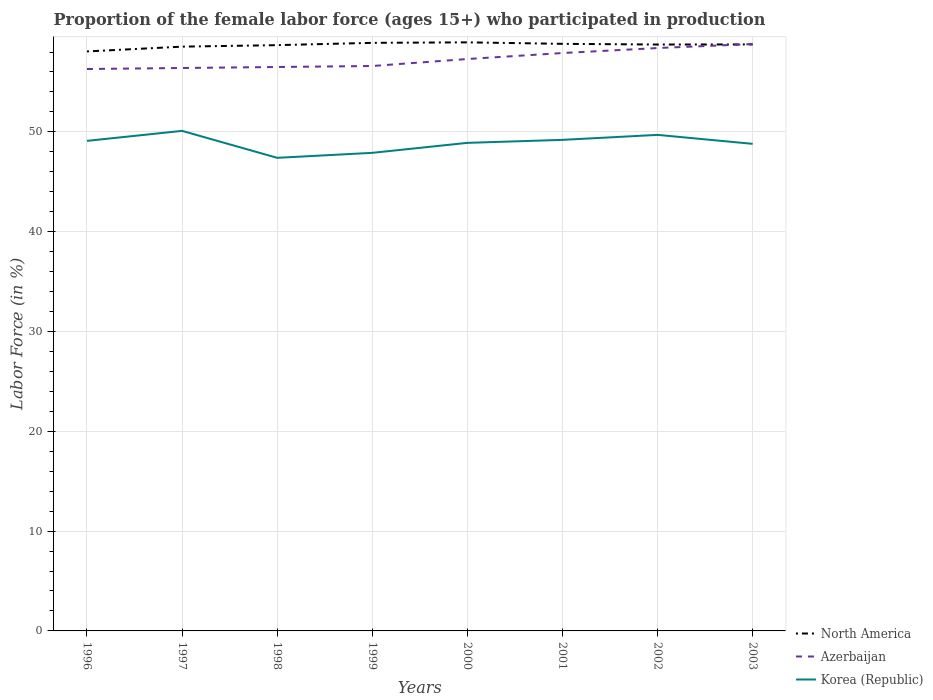How many different coloured lines are there?
Your answer should be compact. 3. Does the line corresponding to Azerbaijan intersect with the line corresponding to North America?
Your answer should be compact. Yes. Is the number of lines equal to the number of legend labels?
Offer a terse response. Yes. Across all years, what is the maximum proportion of the female labor force who participated in production in Azerbaijan?
Make the answer very short. 56.3. What is the total proportion of the female labor force who participated in production in North America in the graph?
Provide a short and direct response. 0.21. What is the difference between the highest and the second highest proportion of the female labor force who participated in production in Korea (Republic)?
Offer a terse response. 2.7. Is the proportion of the female labor force who participated in production in North America strictly greater than the proportion of the female labor force who participated in production in Korea (Republic) over the years?
Ensure brevity in your answer.  No. How many lines are there?
Your response must be concise. 3. How many years are there in the graph?
Provide a succinct answer. 8. What is the difference between two consecutive major ticks on the Y-axis?
Give a very brief answer. 10. Are the values on the major ticks of Y-axis written in scientific E-notation?
Ensure brevity in your answer.  No. Does the graph contain grids?
Provide a succinct answer. Yes. How are the legend labels stacked?
Offer a terse response. Vertical. What is the title of the graph?
Ensure brevity in your answer.  Proportion of the female labor force (ages 15+) who participated in production. Does "Timor-Leste" appear as one of the legend labels in the graph?
Provide a succinct answer. No. What is the label or title of the Y-axis?
Ensure brevity in your answer.  Labor Force (in %). What is the Labor Force (in %) of North America in 1996?
Give a very brief answer. 58.06. What is the Labor Force (in %) in Azerbaijan in 1996?
Keep it short and to the point. 56.3. What is the Labor Force (in %) of Korea (Republic) in 1996?
Offer a terse response. 49.1. What is the Labor Force (in %) of North America in 1997?
Your answer should be very brief. 58.54. What is the Labor Force (in %) in Azerbaijan in 1997?
Provide a succinct answer. 56.4. What is the Labor Force (in %) in Korea (Republic) in 1997?
Give a very brief answer. 50.1. What is the Labor Force (in %) in North America in 1998?
Offer a terse response. 58.69. What is the Labor Force (in %) in Azerbaijan in 1998?
Your answer should be compact. 56.5. What is the Labor Force (in %) in Korea (Republic) in 1998?
Make the answer very short. 47.4. What is the Labor Force (in %) of North America in 1999?
Provide a short and direct response. 58.92. What is the Labor Force (in %) in Azerbaijan in 1999?
Provide a succinct answer. 56.6. What is the Labor Force (in %) in Korea (Republic) in 1999?
Provide a short and direct response. 47.9. What is the Labor Force (in %) in North America in 2000?
Your answer should be compact. 58.97. What is the Labor Force (in %) of Azerbaijan in 2000?
Make the answer very short. 57.3. What is the Labor Force (in %) of Korea (Republic) in 2000?
Offer a terse response. 48.9. What is the Labor Force (in %) of North America in 2001?
Keep it short and to the point. 58.82. What is the Labor Force (in %) of Azerbaijan in 2001?
Provide a succinct answer. 57.9. What is the Labor Force (in %) of Korea (Republic) in 2001?
Provide a succinct answer. 49.2. What is the Labor Force (in %) in North America in 2002?
Offer a very short reply. 58.75. What is the Labor Force (in %) of Azerbaijan in 2002?
Your response must be concise. 58.4. What is the Labor Force (in %) of Korea (Republic) in 2002?
Your response must be concise. 49.7. What is the Labor Force (in %) in North America in 2003?
Offer a very short reply. 58.76. What is the Labor Force (in %) of Azerbaijan in 2003?
Provide a succinct answer. 58.8. What is the Labor Force (in %) of Korea (Republic) in 2003?
Your response must be concise. 48.8. Across all years, what is the maximum Labor Force (in %) of North America?
Keep it short and to the point. 58.97. Across all years, what is the maximum Labor Force (in %) in Azerbaijan?
Provide a succinct answer. 58.8. Across all years, what is the maximum Labor Force (in %) of Korea (Republic)?
Keep it short and to the point. 50.1. Across all years, what is the minimum Labor Force (in %) in North America?
Offer a terse response. 58.06. Across all years, what is the minimum Labor Force (in %) in Azerbaijan?
Your answer should be compact. 56.3. Across all years, what is the minimum Labor Force (in %) in Korea (Republic)?
Give a very brief answer. 47.4. What is the total Labor Force (in %) in North America in the graph?
Provide a short and direct response. 469.51. What is the total Labor Force (in %) of Azerbaijan in the graph?
Keep it short and to the point. 458.2. What is the total Labor Force (in %) in Korea (Republic) in the graph?
Give a very brief answer. 391.1. What is the difference between the Labor Force (in %) in North America in 1996 and that in 1997?
Provide a short and direct response. -0.48. What is the difference between the Labor Force (in %) of North America in 1996 and that in 1998?
Your response must be concise. -0.63. What is the difference between the Labor Force (in %) of North America in 1996 and that in 1999?
Make the answer very short. -0.86. What is the difference between the Labor Force (in %) in Azerbaijan in 1996 and that in 1999?
Your answer should be very brief. -0.3. What is the difference between the Labor Force (in %) of Korea (Republic) in 1996 and that in 1999?
Your answer should be compact. 1.2. What is the difference between the Labor Force (in %) of North America in 1996 and that in 2000?
Provide a short and direct response. -0.91. What is the difference between the Labor Force (in %) of Azerbaijan in 1996 and that in 2000?
Offer a very short reply. -1. What is the difference between the Labor Force (in %) in North America in 1996 and that in 2001?
Your response must be concise. -0.76. What is the difference between the Labor Force (in %) in North America in 1996 and that in 2002?
Keep it short and to the point. -0.69. What is the difference between the Labor Force (in %) of Azerbaijan in 1996 and that in 2002?
Your response must be concise. -2.1. What is the difference between the Labor Force (in %) of North America in 1996 and that in 2003?
Your answer should be compact. -0.7. What is the difference between the Labor Force (in %) in Korea (Republic) in 1996 and that in 2003?
Provide a short and direct response. 0.3. What is the difference between the Labor Force (in %) in North America in 1997 and that in 1998?
Provide a short and direct response. -0.15. What is the difference between the Labor Force (in %) of Korea (Republic) in 1997 and that in 1998?
Make the answer very short. 2.7. What is the difference between the Labor Force (in %) of North America in 1997 and that in 1999?
Offer a very short reply. -0.38. What is the difference between the Labor Force (in %) in Azerbaijan in 1997 and that in 1999?
Keep it short and to the point. -0.2. What is the difference between the Labor Force (in %) in North America in 1997 and that in 2000?
Your answer should be very brief. -0.43. What is the difference between the Labor Force (in %) of Korea (Republic) in 1997 and that in 2000?
Offer a very short reply. 1.2. What is the difference between the Labor Force (in %) in North America in 1997 and that in 2001?
Your response must be concise. -0.28. What is the difference between the Labor Force (in %) of North America in 1997 and that in 2002?
Make the answer very short. -0.21. What is the difference between the Labor Force (in %) of Korea (Republic) in 1997 and that in 2002?
Provide a succinct answer. 0.4. What is the difference between the Labor Force (in %) of North America in 1997 and that in 2003?
Make the answer very short. -0.22. What is the difference between the Labor Force (in %) in Azerbaijan in 1997 and that in 2003?
Keep it short and to the point. -2.4. What is the difference between the Labor Force (in %) of Korea (Republic) in 1997 and that in 2003?
Offer a very short reply. 1.3. What is the difference between the Labor Force (in %) in North America in 1998 and that in 1999?
Provide a succinct answer. -0.23. What is the difference between the Labor Force (in %) in North America in 1998 and that in 2000?
Your answer should be very brief. -0.28. What is the difference between the Labor Force (in %) in North America in 1998 and that in 2001?
Your answer should be compact. -0.13. What is the difference between the Labor Force (in %) in Azerbaijan in 1998 and that in 2001?
Provide a short and direct response. -1.4. What is the difference between the Labor Force (in %) of North America in 1998 and that in 2002?
Provide a succinct answer. -0.06. What is the difference between the Labor Force (in %) of Azerbaijan in 1998 and that in 2002?
Offer a terse response. -1.9. What is the difference between the Labor Force (in %) of North America in 1998 and that in 2003?
Ensure brevity in your answer.  -0.07. What is the difference between the Labor Force (in %) of Azerbaijan in 1998 and that in 2003?
Keep it short and to the point. -2.3. What is the difference between the Labor Force (in %) in Korea (Republic) in 1998 and that in 2003?
Give a very brief answer. -1.4. What is the difference between the Labor Force (in %) in North America in 1999 and that in 2000?
Ensure brevity in your answer.  -0.05. What is the difference between the Labor Force (in %) of Azerbaijan in 1999 and that in 2000?
Your answer should be compact. -0.7. What is the difference between the Labor Force (in %) of North America in 1999 and that in 2001?
Your answer should be compact. 0.1. What is the difference between the Labor Force (in %) in Korea (Republic) in 1999 and that in 2001?
Your answer should be compact. -1.3. What is the difference between the Labor Force (in %) of North America in 1999 and that in 2002?
Ensure brevity in your answer.  0.17. What is the difference between the Labor Force (in %) in Azerbaijan in 1999 and that in 2002?
Offer a very short reply. -1.8. What is the difference between the Labor Force (in %) of North America in 1999 and that in 2003?
Your answer should be very brief. 0.16. What is the difference between the Labor Force (in %) in Korea (Republic) in 1999 and that in 2003?
Your answer should be very brief. -0.9. What is the difference between the Labor Force (in %) of North America in 2000 and that in 2001?
Ensure brevity in your answer.  0.15. What is the difference between the Labor Force (in %) in Azerbaijan in 2000 and that in 2001?
Offer a terse response. -0.6. What is the difference between the Labor Force (in %) of Korea (Republic) in 2000 and that in 2001?
Ensure brevity in your answer.  -0.3. What is the difference between the Labor Force (in %) in North America in 2000 and that in 2002?
Offer a very short reply. 0.22. What is the difference between the Labor Force (in %) of Korea (Republic) in 2000 and that in 2002?
Make the answer very short. -0.8. What is the difference between the Labor Force (in %) in North America in 2000 and that in 2003?
Your answer should be very brief. 0.21. What is the difference between the Labor Force (in %) in Azerbaijan in 2000 and that in 2003?
Provide a short and direct response. -1.5. What is the difference between the Labor Force (in %) of Korea (Republic) in 2000 and that in 2003?
Your answer should be compact. 0.1. What is the difference between the Labor Force (in %) of North America in 2001 and that in 2002?
Your answer should be very brief. 0.07. What is the difference between the Labor Force (in %) in Azerbaijan in 2001 and that in 2002?
Your answer should be compact. -0.5. What is the difference between the Labor Force (in %) of Korea (Republic) in 2001 and that in 2002?
Make the answer very short. -0.5. What is the difference between the Labor Force (in %) in North America in 2001 and that in 2003?
Your answer should be compact. 0.06. What is the difference between the Labor Force (in %) of Azerbaijan in 2001 and that in 2003?
Provide a succinct answer. -0.9. What is the difference between the Labor Force (in %) in North America in 2002 and that in 2003?
Make the answer very short. -0.01. What is the difference between the Labor Force (in %) of North America in 1996 and the Labor Force (in %) of Azerbaijan in 1997?
Offer a terse response. 1.66. What is the difference between the Labor Force (in %) in North America in 1996 and the Labor Force (in %) in Korea (Republic) in 1997?
Offer a terse response. 7.96. What is the difference between the Labor Force (in %) of North America in 1996 and the Labor Force (in %) of Azerbaijan in 1998?
Ensure brevity in your answer.  1.56. What is the difference between the Labor Force (in %) in North America in 1996 and the Labor Force (in %) in Korea (Republic) in 1998?
Your answer should be very brief. 10.66. What is the difference between the Labor Force (in %) in North America in 1996 and the Labor Force (in %) in Azerbaijan in 1999?
Your response must be concise. 1.46. What is the difference between the Labor Force (in %) of North America in 1996 and the Labor Force (in %) of Korea (Republic) in 1999?
Your response must be concise. 10.16. What is the difference between the Labor Force (in %) in North America in 1996 and the Labor Force (in %) in Azerbaijan in 2000?
Offer a terse response. 0.76. What is the difference between the Labor Force (in %) in North America in 1996 and the Labor Force (in %) in Korea (Republic) in 2000?
Provide a short and direct response. 9.16. What is the difference between the Labor Force (in %) in Azerbaijan in 1996 and the Labor Force (in %) in Korea (Republic) in 2000?
Give a very brief answer. 7.4. What is the difference between the Labor Force (in %) of North America in 1996 and the Labor Force (in %) of Azerbaijan in 2001?
Your answer should be compact. 0.16. What is the difference between the Labor Force (in %) in North America in 1996 and the Labor Force (in %) in Korea (Republic) in 2001?
Your response must be concise. 8.86. What is the difference between the Labor Force (in %) of North America in 1996 and the Labor Force (in %) of Azerbaijan in 2002?
Offer a very short reply. -0.34. What is the difference between the Labor Force (in %) of North America in 1996 and the Labor Force (in %) of Korea (Republic) in 2002?
Your response must be concise. 8.36. What is the difference between the Labor Force (in %) in North America in 1996 and the Labor Force (in %) in Azerbaijan in 2003?
Give a very brief answer. -0.74. What is the difference between the Labor Force (in %) in North America in 1996 and the Labor Force (in %) in Korea (Republic) in 2003?
Keep it short and to the point. 9.26. What is the difference between the Labor Force (in %) of North America in 1997 and the Labor Force (in %) of Azerbaijan in 1998?
Ensure brevity in your answer.  2.04. What is the difference between the Labor Force (in %) in North America in 1997 and the Labor Force (in %) in Korea (Republic) in 1998?
Provide a succinct answer. 11.14. What is the difference between the Labor Force (in %) in North America in 1997 and the Labor Force (in %) in Azerbaijan in 1999?
Provide a succinct answer. 1.94. What is the difference between the Labor Force (in %) in North America in 1997 and the Labor Force (in %) in Korea (Republic) in 1999?
Give a very brief answer. 10.64. What is the difference between the Labor Force (in %) of Azerbaijan in 1997 and the Labor Force (in %) of Korea (Republic) in 1999?
Keep it short and to the point. 8.5. What is the difference between the Labor Force (in %) in North America in 1997 and the Labor Force (in %) in Azerbaijan in 2000?
Your response must be concise. 1.24. What is the difference between the Labor Force (in %) of North America in 1997 and the Labor Force (in %) of Korea (Republic) in 2000?
Your answer should be very brief. 9.64. What is the difference between the Labor Force (in %) in North America in 1997 and the Labor Force (in %) in Azerbaijan in 2001?
Offer a terse response. 0.64. What is the difference between the Labor Force (in %) in North America in 1997 and the Labor Force (in %) in Korea (Republic) in 2001?
Provide a short and direct response. 9.34. What is the difference between the Labor Force (in %) of North America in 1997 and the Labor Force (in %) of Azerbaijan in 2002?
Offer a very short reply. 0.14. What is the difference between the Labor Force (in %) of North America in 1997 and the Labor Force (in %) of Korea (Republic) in 2002?
Ensure brevity in your answer.  8.84. What is the difference between the Labor Force (in %) in Azerbaijan in 1997 and the Labor Force (in %) in Korea (Republic) in 2002?
Your response must be concise. 6.7. What is the difference between the Labor Force (in %) of North America in 1997 and the Labor Force (in %) of Azerbaijan in 2003?
Offer a very short reply. -0.26. What is the difference between the Labor Force (in %) in North America in 1997 and the Labor Force (in %) in Korea (Republic) in 2003?
Give a very brief answer. 9.74. What is the difference between the Labor Force (in %) in Azerbaijan in 1997 and the Labor Force (in %) in Korea (Republic) in 2003?
Give a very brief answer. 7.6. What is the difference between the Labor Force (in %) of North America in 1998 and the Labor Force (in %) of Azerbaijan in 1999?
Ensure brevity in your answer.  2.09. What is the difference between the Labor Force (in %) in North America in 1998 and the Labor Force (in %) in Korea (Republic) in 1999?
Provide a short and direct response. 10.79. What is the difference between the Labor Force (in %) in Azerbaijan in 1998 and the Labor Force (in %) in Korea (Republic) in 1999?
Keep it short and to the point. 8.6. What is the difference between the Labor Force (in %) of North America in 1998 and the Labor Force (in %) of Azerbaijan in 2000?
Your response must be concise. 1.39. What is the difference between the Labor Force (in %) of North America in 1998 and the Labor Force (in %) of Korea (Republic) in 2000?
Provide a succinct answer. 9.79. What is the difference between the Labor Force (in %) of North America in 1998 and the Labor Force (in %) of Azerbaijan in 2001?
Provide a short and direct response. 0.79. What is the difference between the Labor Force (in %) of North America in 1998 and the Labor Force (in %) of Korea (Republic) in 2001?
Your response must be concise. 9.49. What is the difference between the Labor Force (in %) in Azerbaijan in 1998 and the Labor Force (in %) in Korea (Republic) in 2001?
Provide a succinct answer. 7.3. What is the difference between the Labor Force (in %) of North America in 1998 and the Labor Force (in %) of Azerbaijan in 2002?
Your response must be concise. 0.29. What is the difference between the Labor Force (in %) in North America in 1998 and the Labor Force (in %) in Korea (Republic) in 2002?
Provide a succinct answer. 8.99. What is the difference between the Labor Force (in %) of North America in 1998 and the Labor Force (in %) of Azerbaijan in 2003?
Ensure brevity in your answer.  -0.11. What is the difference between the Labor Force (in %) in North America in 1998 and the Labor Force (in %) in Korea (Republic) in 2003?
Your answer should be compact. 9.89. What is the difference between the Labor Force (in %) of North America in 1999 and the Labor Force (in %) of Azerbaijan in 2000?
Provide a short and direct response. 1.62. What is the difference between the Labor Force (in %) in North America in 1999 and the Labor Force (in %) in Korea (Republic) in 2000?
Keep it short and to the point. 10.02. What is the difference between the Labor Force (in %) in North America in 1999 and the Labor Force (in %) in Azerbaijan in 2001?
Provide a succinct answer. 1.02. What is the difference between the Labor Force (in %) of North America in 1999 and the Labor Force (in %) of Korea (Republic) in 2001?
Make the answer very short. 9.72. What is the difference between the Labor Force (in %) in North America in 1999 and the Labor Force (in %) in Azerbaijan in 2002?
Give a very brief answer. 0.52. What is the difference between the Labor Force (in %) in North America in 1999 and the Labor Force (in %) in Korea (Republic) in 2002?
Keep it short and to the point. 9.22. What is the difference between the Labor Force (in %) of North America in 1999 and the Labor Force (in %) of Azerbaijan in 2003?
Your answer should be compact. 0.12. What is the difference between the Labor Force (in %) in North America in 1999 and the Labor Force (in %) in Korea (Republic) in 2003?
Your answer should be compact. 10.12. What is the difference between the Labor Force (in %) in Azerbaijan in 1999 and the Labor Force (in %) in Korea (Republic) in 2003?
Provide a short and direct response. 7.8. What is the difference between the Labor Force (in %) of North America in 2000 and the Labor Force (in %) of Azerbaijan in 2001?
Your answer should be very brief. 1.07. What is the difference between the Labor Force (in %) of North America in 2000 and the Labor Force (in %) of Korea (Republic) in 2001?
Provide a succinct answer. 9.77. What is the difference between the Labor Force (in %) of Azerbaijan in 2000 and the Labor Force (in %) of Korea (Republic) in 2001?
Provide a short and direct response. 8.1. What is the difference between the Labor Force (in %) in North America in 2000 and the Labor Force (in %) in Azerbaijan in 2002?
Make the answer very short. 0.57. What is the difference between the Labor Force (in %) in North America in 2000 and the Labor Force (in %) in Korea (Republic) in 2002?
Provide a succinct answer. 9.27. What is the difference between the Labor Force (in %) of Azerbaijan in 2000 and the Labor Force (in %) of Korea (Republic) in 2002?
Keep it short and to the point. 7.6. What is the difference between the Labor Force (in %) of North America in 2000 and the Labor Force (in %) of Azerbaijan in 2003?
Your answer should be very brief. 0.17. What is the difference between the Labor Force (in %) in North America in 2000 and the Labor Force (in %) in Korea (Republic) in 2003?
Offer a very short reply. 10.17. What is the difference between the Labor Force (in %) of Azerbaijan in 2000 and the Labor Force (in %) of Korea (Republic) in 2003?
Your answer should be very brief. 8.5. What is the difference between the Labor Force (in %) of North America in 2001 and the Labor Force (in %) of Azerbaijan in 2002?
Your answer should be very brief. 0.42. What is the difference between the Labor Force (in %) of North America in 2001 and the Labor Force (in %) of Korea (Republic) in 2002?
Ensure brevity in your answer.  9.12. What is the difference between the Labor Force (in %) in Azerbaijan in 2001 and the Labor Force (in %) in Korea (Republic) in 2002?
Give a very brief answer. 8.2. What is the difference between the Labor Force (in %) of North America in 2001 and the Labor Force (in %) of Azerbaijan in 2003?
Your answer should be very brief. 0.02. What is the difference between the Labor Force (in %) in North America in 2001 and the Labor Force (in %) in Korea (Republic) in 2003?
Provide a short and direct response. 10.02. What is the difference between the Labor Force (in %) of North America in 2002 and the Labor Force (in %) of Azerbaijan in 2003?
Offer a very short reply. -0.05. What is the difference between the Labor Force (in %) of North America in 2002 and the Labor Force (in %) of Korea (Republic) in 2003?
Your answer should be compact. 9.95. What is the difference between the Labor Force (in %) of Azerbaijan in 2002 and the Labor Force (in %) of Korea (Republic) in 2003?
Your answer should be compact. 9.6. What is the average Labor Force (in %) of North America per year?
Keep it short and to the point. 58.69. What is the average Labor Force (in %) in Azerbaijan per year?
Make the answer very short. 57.27. What is the average Labor Force (in %) of Korea (Republic) per year?
Your response must be concise. 48.89. In the year 1996, what is the difference between the Labor Force (in %) of North America and Labor Force (in %) of Azerbaijan?
Keep it short and to the point. 1.76. In the year 1996, what is the difference between the Labor Force (in %) in North America and Labor Force (in %) in Korea (Republic)?
Keep it short and to the point. 8.96. In the year 1997, what is the difference between the Labor Force (in %) of North America and Labor Force (in %) of Azerbaijan?
Your answer should be compact. 2.14. In the year 1997, what is the difference between the Labor Force (in %) of North America and Labor Force (in %) of Korea (Republic)?
Give a very brief answer. 8.44. In the year 1997, what is the difference between the Labor Force (in %) in Azerbaijan and Labor Force (in %) in Korea (Republic)?
Provide a short and direct response. 6.3. In the year 1998, what is the difference between the Labor Force (in %) of North America and Labor Force (in %) of Azerbaijan?
Your answer should be compact. 2.19. In the year 1998, what is the difference between the Labor Force (in %) in North America and Labor Force (in %) in Korea (Republic)?
Keep it short and to the point. 11.29. In the year 1998, what is the difference between the Labor Force (in %) in Azerbaijan and Labor Force (in %) in Korea (Republic)?
Give a very brief answer. 9.1. In the year 1999, what is the difference between the Labor Force (in %) in North America and Labor Force (in %) in Azerbaijan?
Provide a short and direct response. 2.32. In the year 1999, what is the difference between the Labor Force (in %) in North America and Labor Force (in %) in Korea (Republic)?
Provide a short and direct response. 11.02. In the year 1999, what is the difference between the Labor Force (in %) in Azerbaijan and Labor Force (in %) in Korea (Republic)?
Offer a terse response. 8.7. In the year 2000, what is the difference between the Labor Force (in %) of North America and Labor Force (in %) of Azerbaijan?
Give a very brief answer. 1.67. In the year 2000, what is the difference between the Labor Force (in %) in North America and Labor Force (in %) in Korea (Republic)?
Your answer should be very brief. 10.07. In the year 2001, what is the difference between the Labor Force (in %) of North America and Labor Force (in %) of Azerbaijan?
Your answer should be very brief. 0.92. In the year 2001, what is the difference between the Labor Force (in %) of North America and Labor Force (in %) of Korea (Republic)?
Give a very brief answer. 9.62. In the year 2002, what is the difference between the Labor Force (in %) in North America and Labor Force (in %) in Azerbaijan?
Offer a terse response. 0.35. In the year 2002, what is the difference between the Labor Force (in %) in North America and Labor Force (in %) in Korea (Republic)?
Make the answer very short. 9.05. In the year 2002, what is the difference between the Labor Force (in %) of Azerbaijan and Labor Force (in %) of Korea (Republic)?
Offer a terse response. 8.7. In the year 2003, what is the difference between the Labor Force (in %) in North America and Labor Force (in %) in Azerbaijan?
Provide a short and direct response. -0.04. In the year 2003, what is the difference between the Labor Force (in %) of North America and Labor Force (in %) of Korea (Republic)?
Keep it short and to the point. 9.96. In the year 2003, what is the difference between the Labor Force (in %) of Azerbaijan and Labor Force (in %) of Korea (Republic)?
Make the answer very short. 10. What is the ratio of the Labor Force (in %) of Azerbaijan in 1996 to that in 1997?
Your answer should be compact. 1. What is the ratio of the Labor Force (in %) in Korea (Republic) in 1996 to that in 1997?
Provide a succinct answer. 0.98. What is the ratio of the Labor Force (in %) in North America in 1996 to that in 1998?
Give a very brief answer. 0.99. What is the ratio of the Labor Force (in %) of Azerbaijan in 1996 to that in 1998?
Keep it short and to the point. 1. What is the ratio of the Labor Force (in %) of Korea (Republic) in 1996 to that in 1998?
Offer a terse response. 1.04. What is the ratio of the Labor Force (in %) in North America in 1996 to that in 1999?
Ensure brevity in your answer.  0.99. What is the ratio of the Labor Force (in %) of Korea (Republic) in 1996 to that in 1999?
Offer a very short reply. 1.03. What is the ratio of the Labor Force (in %) in North America in 1996 to that in 2000?
Give a very brief answer. 0.98. What is the ratio of the Labor Force (in %) of Azerbaijan in 1996 to that in 2000?
Your answer should be compact. 0.98. What is the ratio of the Labor Force (in %) of Korea (Republic) in 1996 to that in 2000?
Your answer should be very brief. 1. What is the ratio of the Labor Force (in %) of North America in 1996 to that in 2001?
Provide a short and direct response. 0.99. What is the ratio of the Labor Force (in %) in Azerbaijan in 1996 to that in 2001?
Keep it short and to the point. 0.97. What is the ratio of the Labor Force (in %) in Korea (Republic) in 1996 to that in 2002?
Offer a terse response. 0.99. What is the ratio of the Labor Force (in %) of Azerbaijan in 1996 to that in 2003?
Your answer should be very brief. 0.96. What is the ratio of the Labor Force (in %) of Azerbaijan in 1997 to that in 1998?
Offer a very short reply. 1. What is the ratio of the Labor Force (in %) of Korea (Republic) in 1997 to that in 1998?
Ensure brevity in your answer.  1.06. What is the ratio of the Labor Force (in %) in Azerbaijan in 1997 to that in 1999?
Keep it short and to the point. 1. What is the ratio of the Labor Force (in %) of Korea (Republic) in 1997 to that in 1999?
Ensure brevity in your answer.  1.05. What is the ratio of the Labor Force (in %) in Azerbaijan in 1997 to that in 2000?
Your answer should be very brief. 0.98. What is the ratio of the Labor Force (in %) of Korea (Republic) in 1997 to that in 2000?
Make the answer very short. 1.02. What is the ratio of the Labor Force (in %) in Azerbaijan in 1997 to that in 2001?
Offer a terse response. 0.97. What is the ratio of the Labor Force (in %) of Korea (Republic) in 1997 to that in 2001?
Your answer should be very brief. 1.02. What is the ratio of the Labor Force (in %) of Azerbaijan in 1997 to that in 2002?
Keep it short and to the point. 0.97. What is the ratio of the Labor Force (in %) in Korea (Republic) in 1997 to that in 2002?
Keep it short and to the point. 1.01. What is the ratio of the Labor Force (in %) of Azerbaijan in 1997 to that in 2003?
Give a very brief answer. 0.96. What is the ratio of the Labor Force (in %) of Korea (Republic) in 1997 to that in 2003?
Offer a terse response. 1.03. What is the ratio of the Labor Force (in %) in Azerbaijan in 1998 to that in 1999?
Your response must be concise. 1. What is the ratio of the Labor Force (in %) in Korea (Republic) in 1998 to that in 1999?
Your response must be concise. 0.99. What is the ratio of the Labor Force (in %) of North America in 1998 to that in 2000?
Provide a short and direct response. 1. What is the ratio of the Labor Force (in %) in Korea (Republic) in 1998 to that in 2000?
Your answer should be compact. 0.97. What is the ratio of the Labor Force (in %) in Azerbaijan in 1998 to that in 2001?
Your response must be concise. 0.98. What is the ratio of the Labor Force (in %) in Korea (Republic) in 1998 to that in 2001?
Your response must be concise. 0.96. What is the ratio of the Labor Force (in %) of Azerbaijan in 1998 to that in 2002?
Your answer should be compact. 0.97. What is the ratio of the Labor Force (in %) of Korea (Republic) in 1998 to that in 2002?
Your answer should be compact. 0.95. What is the ratio of the Labor Force (in %) in Azerbaijan in 1998 to that in 2003?
Offer a very short reply. 0.96. What is the ratio of the Labor Force (in %) in Korea (Republic) in 1998 to that in 2003?
Your answer should be very brief. 0.97. What is the ratio of the Labor Force (in %) of Korea (Republic) in 1999 to that in 2000?
Give a very brief answer. 0.98. What is the ratio of the Labor Force (in %) in Azerbaijan in 1999 to that in 2001?
Your answer should be compact. 0.98. What is the ratio of the Labor Force (in %) of Korea (Republic) in 1999 to that in 2001?
Provide a succinct answer. 0.97. What is the ratio of the Labor Force (in %) of North America in 1999 to that in 2002?
Ensure brevity in your answer.  1. What is the ratio of the Labor Force (in %) in Azerbaijan in 1999 to that in 2002?
Offer a very short reply. 0.97. What is the ratio of the Labor Force (in %) in Korea (Republic) in 1999 to that in 2002?
Your response must be concise. 0.96. What is the ratio of the Labor Force (in %) of Azerbaijan in 1999 to that in 2003?
Keep it short and to the point. 0.96. What is the ratio of the Labor Force (in %) in Korea (Republic) in 1999 to that in 2003?
Your answer should be very brief. 0.98. What is the ratio of the Labor Force (in %) of Azerbaijan in 2000 to that in 2002?
Offer a terse response. 0.98. What is the ratio of the Labor Force (in %) in Korea (Republic) in 2000 to that in 2002?
Your answer should be compact. 0.98. What is the ratio of the Labor Force (in %) in Azerbaijan in 2000 to that in 2003?
Give a very brief answer. 0.97. What is the ratio of the Labor Force (in %) of North America in 2001 to that in 2002?
Your answer should be very brief. 1. What is the ratio of the Labor Force (in %) of Azerbaijan in 2001 to that in 2002?
Your answer should be compact. 0.99. What is the ratio of the Labor Force (in %) of Korea (Republic) in 2001 to that in 2002?
Ensure brevity in your answer.  0.99. What is the ratio of the Labor Force (in %) of North America in 2001 to that in 2003?
Provide a short and direct response. 1. What is the ratio of the Labor Force (in %) of Azerbaijan in 2001 to that in 2003?
Provide a succinct answer. 0.98. What is the ratio of the Labor Force (in %) of Korea (Republic) in 2001 to that in 2003?
Give a very brief answer. 1.01. What is the ratio of the Labor Force (in %) in North America in 2002 to that in 2003?
Make the answer very short. 1. What is the ratio of the Labor Force (in %) of Korea (Republic) in 2002 to that in 2003?
Offer a terse response. 1.02. What is the difference between the highest and the second highest Labor Force (in %) of North America?
Offer a very short reply. 0.05. What is the difference between the highest and the second highest Labor Force (in %) of Azerbaijan?
Your answer should be compact. 0.4. What is the difference between the highest and the lowest Labor Force (in %) in North America?
Give a very brief answer. 0.91. What is the difference between the highest and the lowest Labor Force (in %) in Korea (Republic)?
Offer a very short reply. 2.7. 